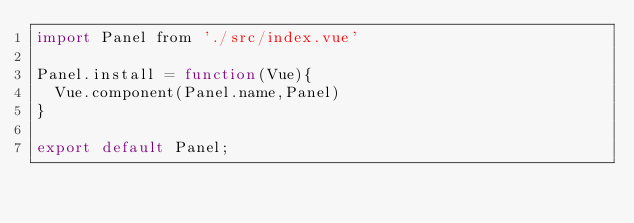Convert code to text. <code><loc_0><loc_0><loc_500><loc_500><_JavaScript_>import Panel from './src/index.vue'

Panel.install = function(Vue){
  Vue.component(Panel.name,Panel)
}

export default Panel;
</code> 